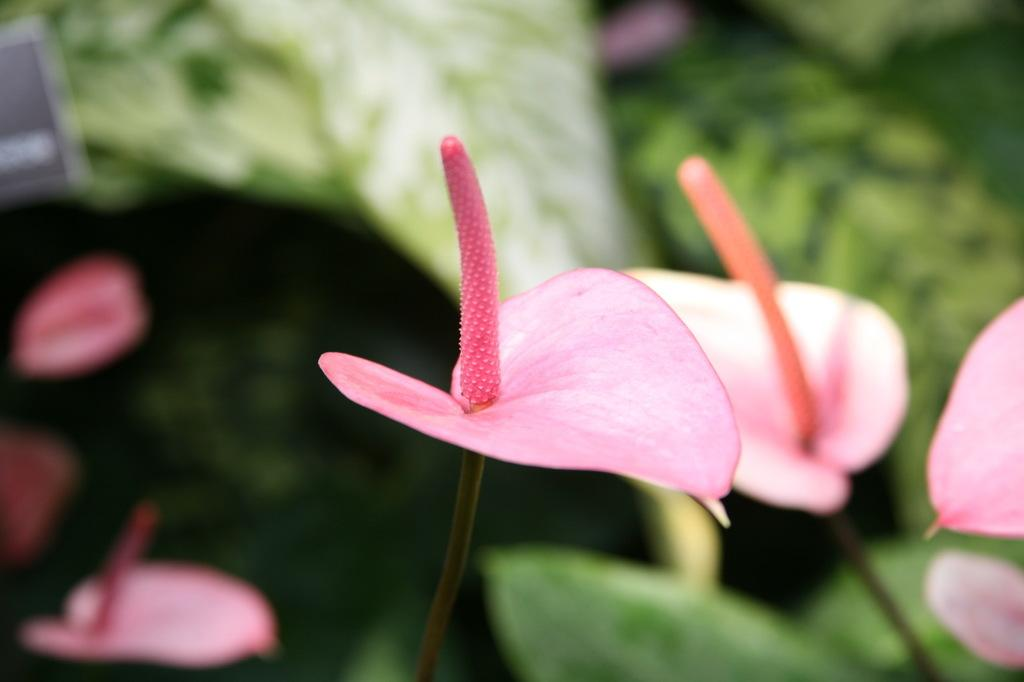What type of plant is present in the image? There are flowers on a plant in the image. Can you describe the appearance of the leaves in the image? The leaves are visible in the image, but they appear blurry. Is there a fight or war happening in the image? No, there is no fight or war depicted in the image. Can you see someone skateboarding in the image? No, there is no skateboarding or any indication of a skateboard in the image. 